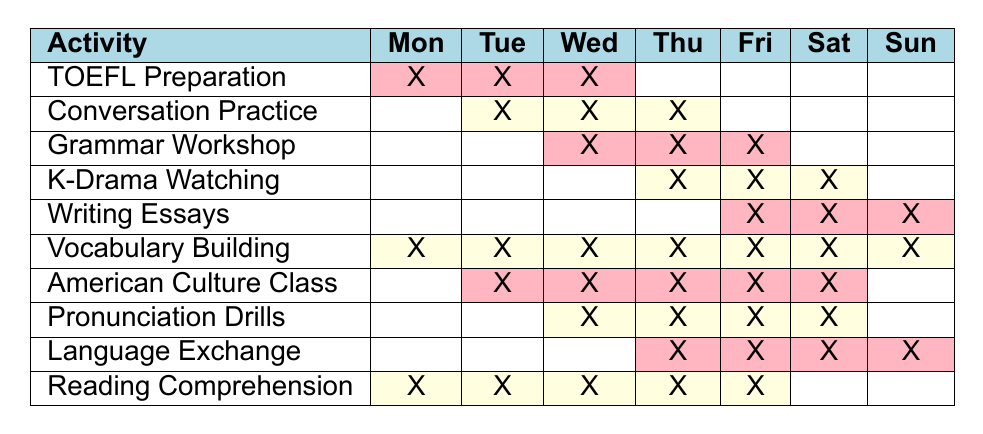What activities are scheduled on Monday? To answer this, look at the "Mon" column and identify the activities marked with an "X". The activities are: TOEFL Preparation, Vocabulary Building, and Reading Comprehension.
Answer: TOEFL Preparation, Vocabulary Building, Reading Comprehension Which activity has the longest duration in the schedule? The activity with the longest duration can be determined by finding the number of columns (days) marked with an "X". Vocabulary Building is marked every day of the week, making its duration 7 days.
Answer: Vocabulary Building Are there any activities scheduled on Sunday? Check the "Sun" column for any marked activities. There are no activities marked with an "X" in the Sunday column.
Answer: No How many activities occur on Friday? Count the number of activities marked with an "X" in the "Fri" column. The activities are: Writing Essays, Vocabulary Building, American Culture Class, and Language Exchange, totaling 4 activities.
Answer: 4 Which days have "Conversation Practice" scheduled? Look for the row labeled "Conversation Practice" and note the days with an "X" in that row. It occurs on Tuesday, Wednesday, and Thursday.
Answer: Tuesday, Wednesday, Thursday What is the total number of unique activities scheduled throughout the week? Count the distinct activity names listed in the table. There are 10 unique activities present.
Answer: 10 Is "Pronunciation Drills" scheduled for all weekdays? Check the columns Tuesday through Friday (the weekdays) to see if there's an "X" in each column for Pronunciation Drills. It's scheduled only on Wednesday, Thursday, and Friday, not all weekdays.
Answer: No Which activity has the least overlap with others on Thursday? Examine the Thursday column for any marked activities. K-Drama Watching is the only one, as all others are scheduled on more days.
Answer: K-Drama Watching How many total hours are dedicated to "Vocabulary Building"? Since Vocabulary Building is scheduled every day of the week, it has 7 days, implying a total of 7 hours dedicated to it (assuming one activity hour per day).
Answer: 7 Is there any day of the week that does not have any scheduled activities at all? Review each day to find any column without "X" marks. Both Monday and Sunday have scheduled activities; however, Saturday has no activities scheduled (it shows empty for all).
Answer: Yes, Saturday has no activities 